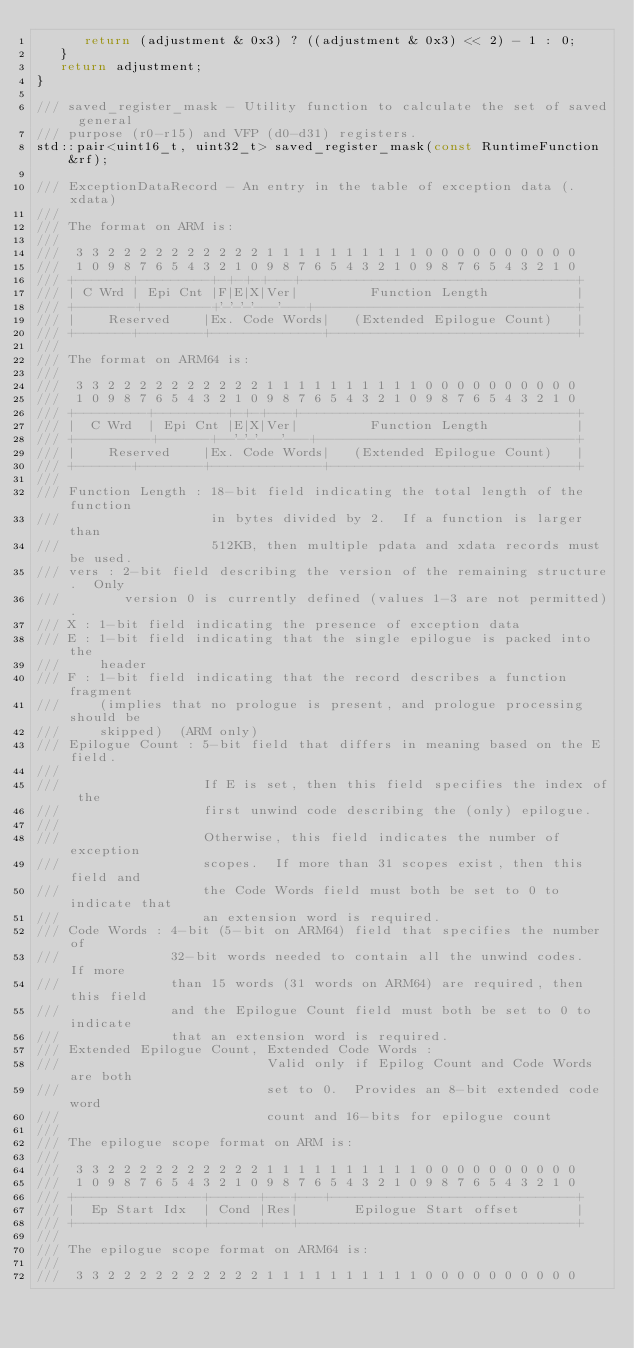Convert code to text. <code><loc_0><loc_0><loc_500><loc_500><_C_>      return (adjustment & 0x3) ? ((adjustment & 0x3) << 2) - 1 : 0;
   }
   return adjustment;
}

/// saved_register_mask - Utility function to calculate the set of saved general
/// purpose (r0-r15) and VFP (d0-d31) registers.
std::pair<uint16_t, uint32_t> saved_register_mask(const RuntimeFunction &rf);

/// ExceptionDataRecord - An entry in the table of exception data (.xdata)
///
/// The format on ARM is:
///
///  3 3 2 2 2 2 2 2 2 2 2 2 1 1 1 1 1 1 1 1 1 1 0 0 0 0 0 0 0 0 0 0
///  1 0 9 8 7 6 5 4 3 2 1 0 9 8 7 6 5 4 3 2 1 0 9 8 7 6 5 4 3 2 1 0
/// +-------+---------+-+-+-+---+-----------------------------------+
/// | C Wrd | Epi Cnt |F|E|X|Ver|         Function Length           |
/// +-------+--------+'-'-'-'---'---+-------------------------------+
/// |    Reserved    |Ex. Code Words|   (Extended Epilogue Count)   |
/// +-------+--------+--------------+-------------------------------+
///
/// The format on ARM64 is:
///
///  3 3 2 2 2 2 2 2 2 2 2 2 1 1 1 1 1 1 1 1 1 1 0 0 0 0 0 0 0 0 0 0
///  1 0 9 8 7 6 5 4 3 2 1 0 9 8 7 6 5 4 3 2 1 0 9 8 7 6 5 4 3 2 1 0
/// +---------+---------+-+-+---+-----------------------------------+
/// |  C Wrd  | Epi Cnt |E|X|Ver|         Function Length           |
/// +---------+------+--'-'-'---'---+-------------------------------+
/// |    Reserved    |Ex. Code Words|   (Extended Epilogue Count)   |
/// +-------+--------+--------------+-------------------------------+
///
/// Function Length : 18-bit field indicating the total length of the function
///                   in bytes divided by 2.  If a function is larger than
///                   512KB, then multiple pdata and xdata records must be used.
/// vers : 2-bit field describing the version of the remaining structure.  Only
///        version 0 is currently defined (values 1-3 are not permitted).
/// X : 1-bit field indicating the presence of exception data
/// E : 1-bit field indicating that the single epilogue is packed into the
///     header
/// F : 1-bit field indicating that the record describes a function fragment
///     (implies that no prologue is present, and prologue processing should be
///     skipped)  (ARM only)
/// Epilogue Count : 5-bit field that differs in meaning based on the E field.
///
///                  If E is set, then this field specifies the index of the
///                  first unwind code describing the (only) epilogue.
///
///                  Otherwise, this field indicates the number of exception
///                  scopes.  If more than 31 scopes exist, then this field and
///                  the Code Words field must both be set to 0 to indicate that
///                  an extension word is required.
/// Code Words : 4-bit (5-bit on ARM64) field that specifies the number of
///              32-bit words needed to contain all the unwind codes.  If more
///              than 15 words (31 words on ARM64) are required, then this field
///              and the Epilogue Count field must both be set to 0 to indicate
///              that an extension word is required.
/// Extended Epilogue Count, Extended Code Words :
///                          Valid only if Epilog Count and Code Words are both
///                          set to 0.  Provides an 8-bit extended code word
///                          count and 16-bits for epilogue count
///
/// The epilogue scope format on ARM is:
///
///  3 3 2 2 2 2 2 2 2 2 2 2 1 1 1 1 1 1 1 1 1 1 0 0 0 0 0 0 0 0 0 0
///  1 0 9 8 7 6 5 4 3 2 1 0 9 8 7 6 5 4 3 2 1 0 9 8 7 6 5 4 3 2 1 0
/// +----------------+------+---+---+-------------------------------+
/// |  Ep Start Idx  | Cond |Res|       Epilogue Start offset       |
/// +----------------+------+---+-----------------------------------+
///
/// The epilogue scope format on ARM64 is:
///
///  3 3 2 2 2 2 2 2 2 2 2 2 1 1 1 1 1 1 1 1 1 1 0 0 0 0 0 0 0 0 0 0</code> 